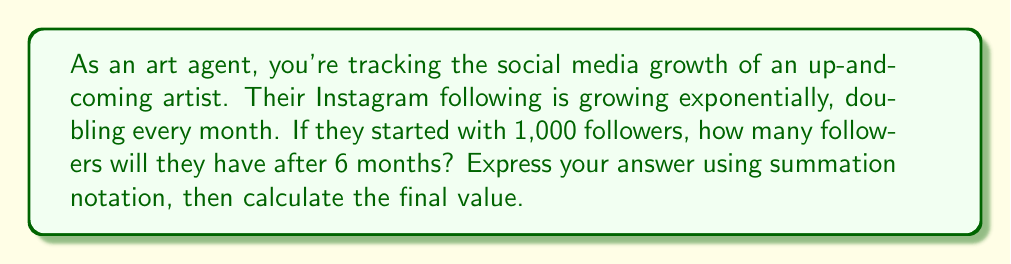Show me your answer to this math problem. Let's approach this step-by-step:

1) The initial number of followers is 1,000.

2) The number of followers doubles every month, so we can represent this as a geometric sequence with a common ratio of 2.

3) After n months, the number of followers will be:

   $1000 \cdot 2^n$

4) To find the total number of followers after 6 months, we need to sum this expression from n = 0 to n = 6:

   $$\sum_{n=0}^6 1000 \cdot 2^n$$

5) This is a geometric series with:
   - First term $a = 1000$
   - Common ratio $r = 2$
   - Number of terms $n = 7$ (remember, we're including the initial state, n = 0)

6) The sum of a geometric series is given by the formula:

   $$S_n = a\frac{1-r^n}{1-r}$$

   where $S_n$ is the sum of n terms.

7) Substituting our values:

   $$S_7 = 1000\frac{1-2^7}{1-2} = 1000\frac{1-128}{-1} = 1000(127) = 127,000$$

Therefore, after 6 months, the artist will have 127,000 followers.
Answer: $$\sum_{n=0}^6 1000 \cdot 2^n = 127,000$$ followers 